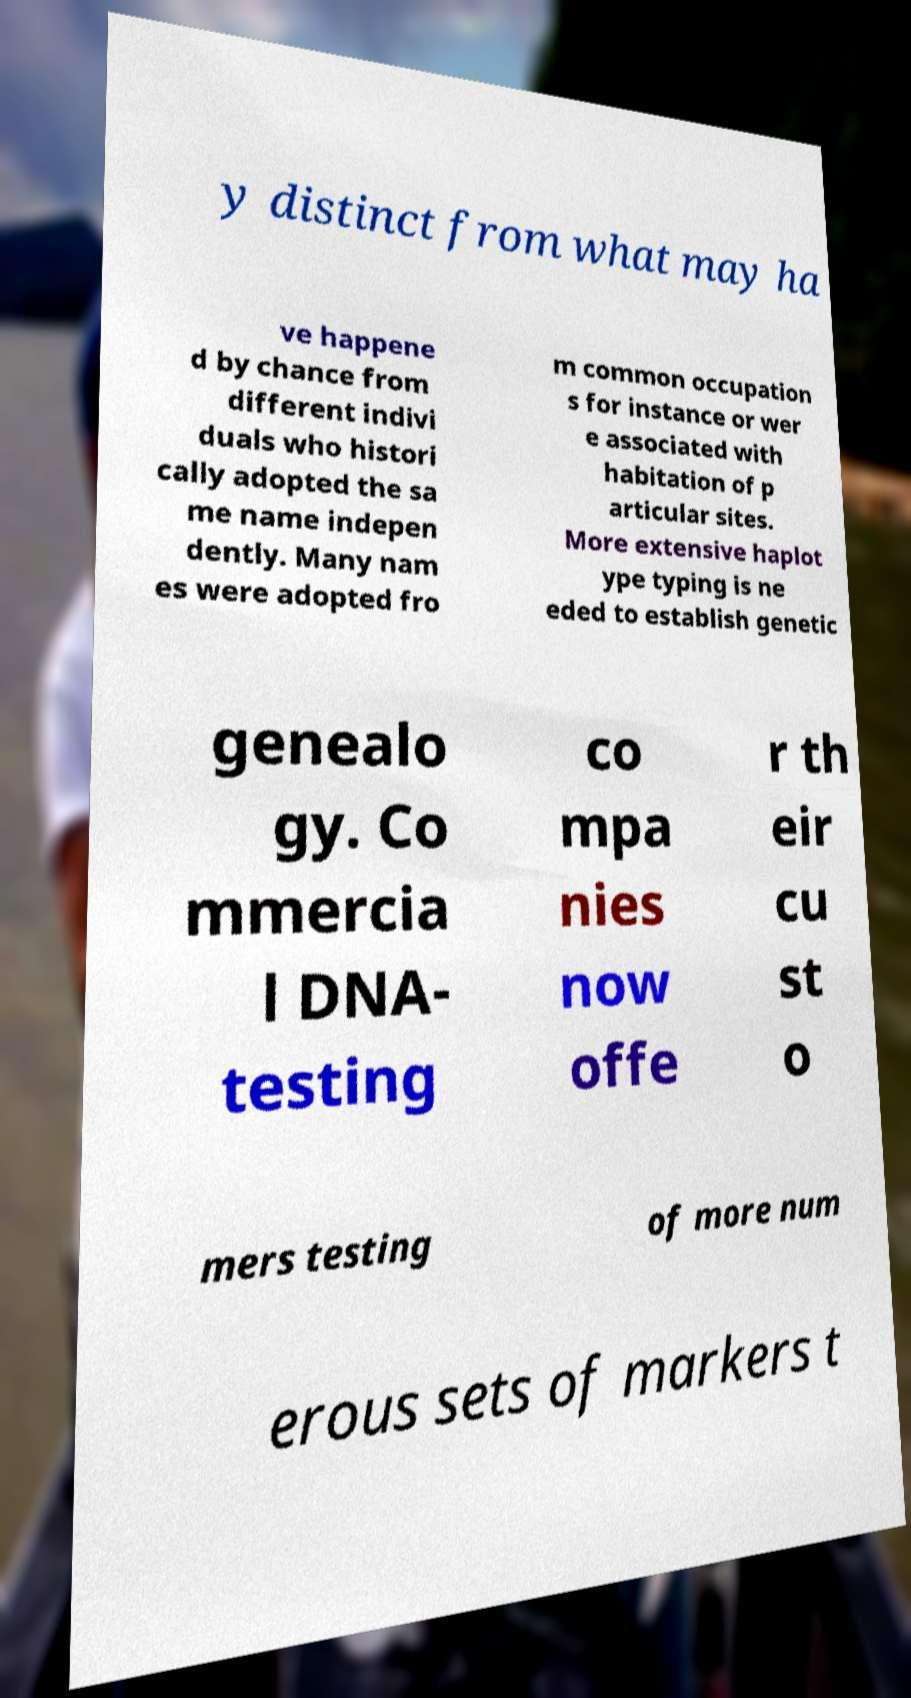What messages or text are displayed in this image? I need them in a readable, typed format. y distinct from what may ha ve happene d by chance from different indivi duals who histori cally adopted the sa me name indepen dently. Many nam es were adopted fro m common occupation s for instance or wer e associated with habitation of p articular sites. More extensive haplot ype typing is ne eded to establish genetic genealo gy. Co mmercia l DNA- testing co mpa nies now offe r th eir cu st o mers testing of more num erous sets of markers t 